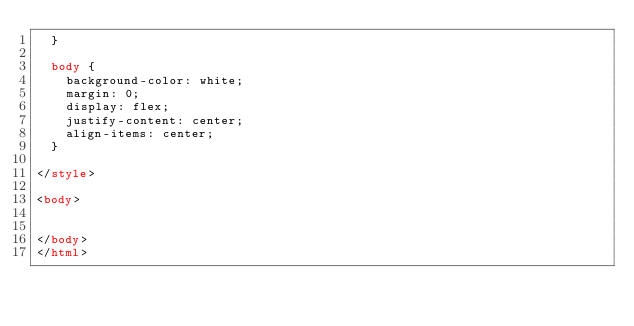Convert code to text. <code><loc_0><loc_0><loc_500><loc_500><_HTML_>  }

  body {
    background-color: white;
    margin: 0;
    display: flex;
    justify-content: center;
    align-items: center;
  }

</style>

<body>


</body>
</html>
</code> 